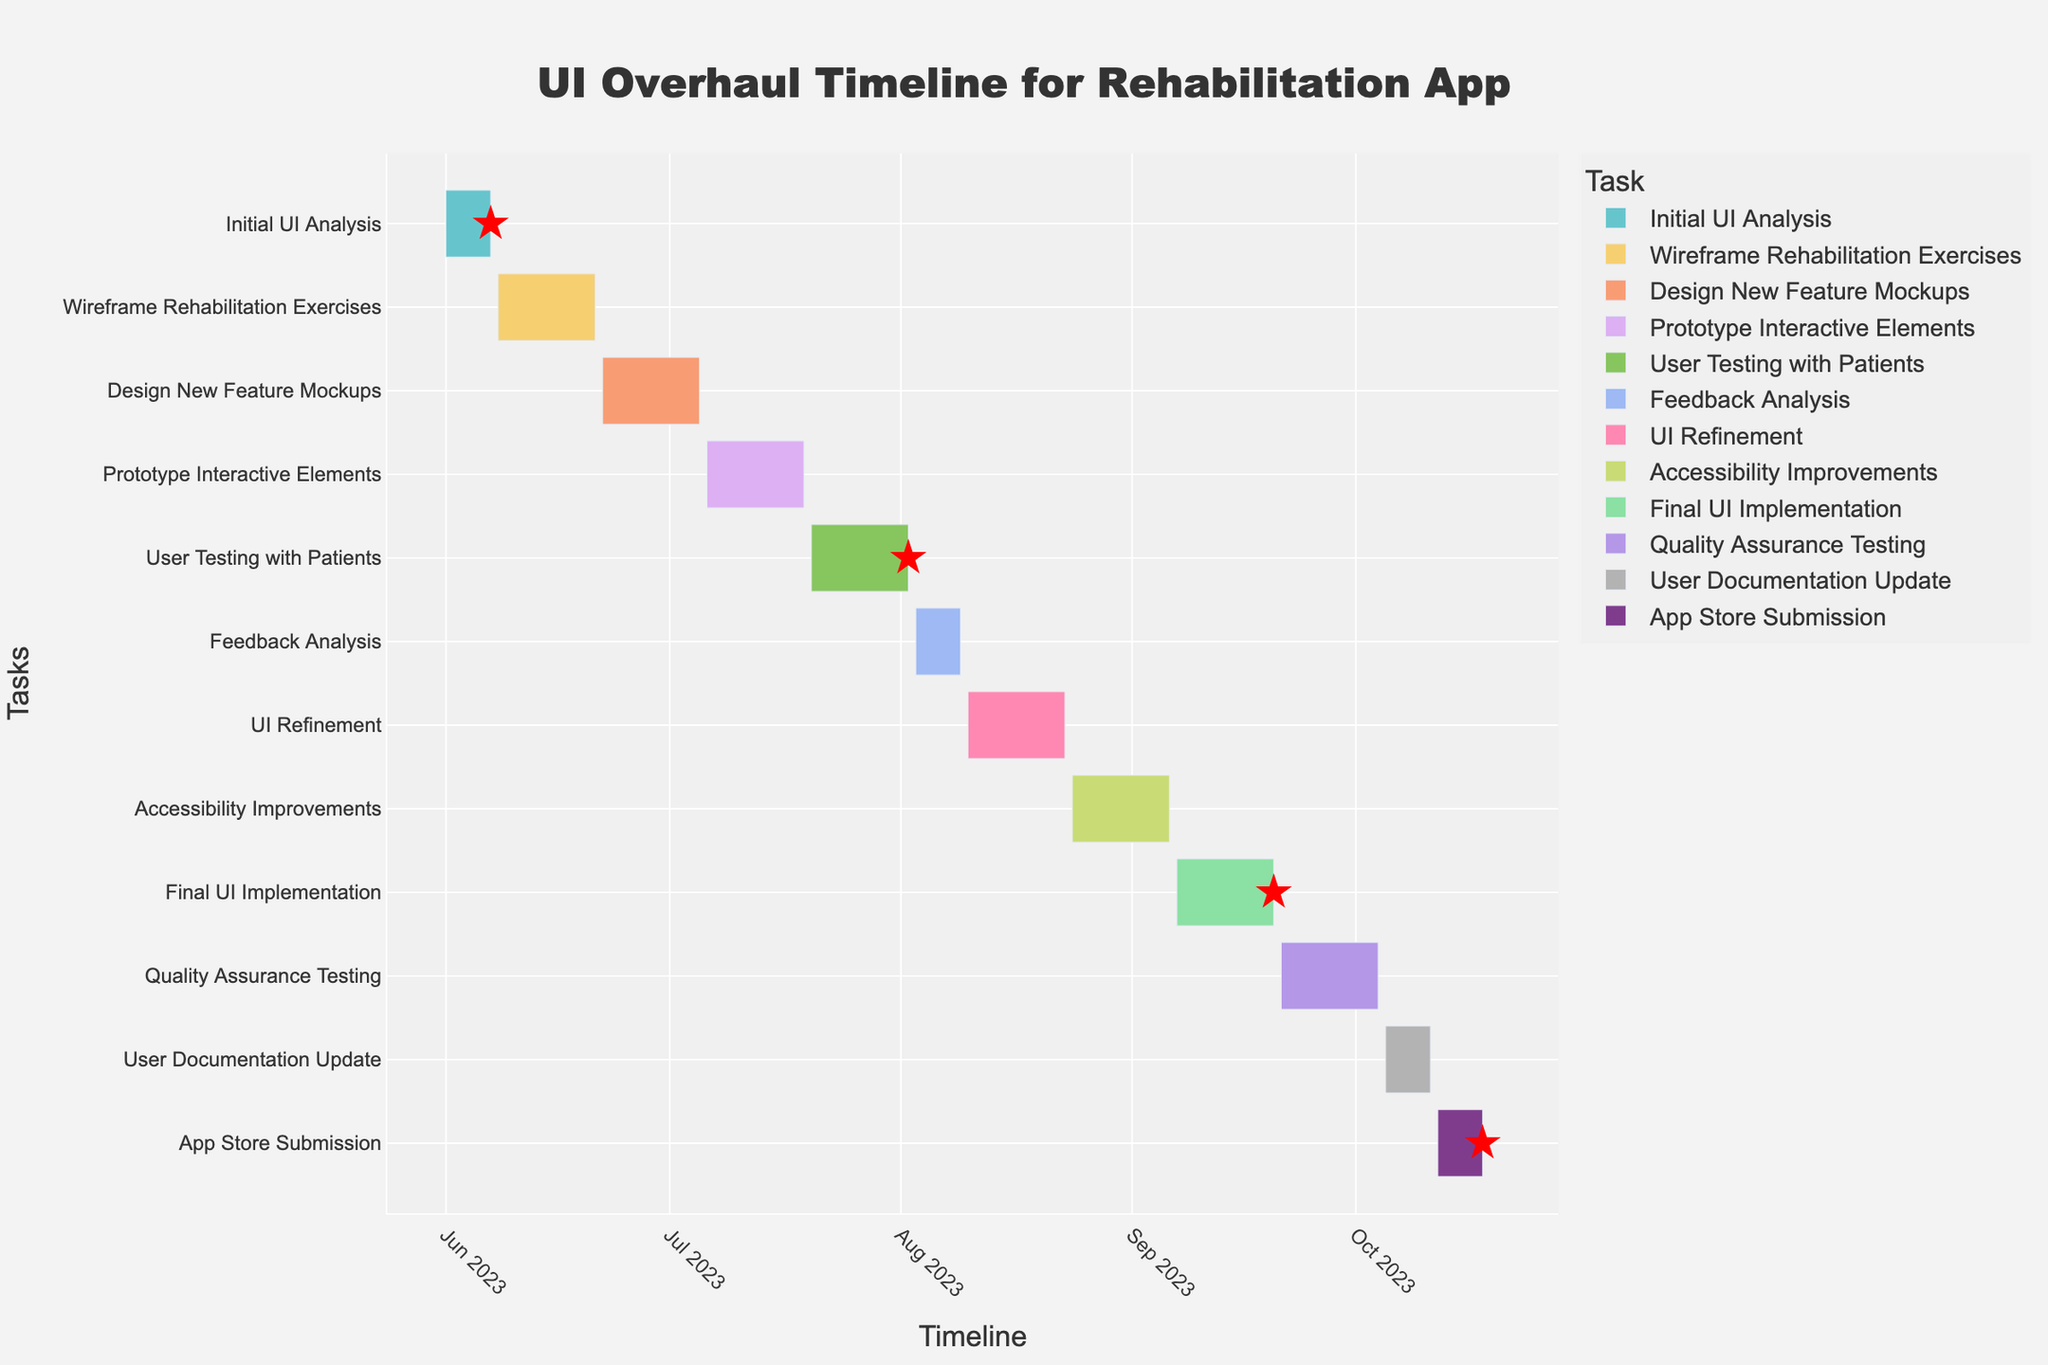What is the title of the Gantt Chart? The title is displayed at the top center of the chart, indicating the overall purpose of the visual. The title of the Gantt Chart reads "UI Overhaul Timeline for Rehabilitation App".
Answer: UI Overhaul Timeline for Rehabilitation App How long is the duration for the "Wireframe Rehabilitation Exercises" task? The "Wireframe Rehabilitation Exercises" task is represented by a bar on the Gantt Chart, and the duration is indicated in days. By referring to the hover information or the duration column, we can see it lasts for 14 days.
Answer: 14 days Between which dates does the "User Testing with Patients" phase occur? The "User Testing with Patients" bar is shown on the Gantt Chart with both start and end dates visible. It starts on July 20, 2023, and ends on August 2, 2023.
Answer: July 20, 2023 - August 2, 2023 Which task is scheduled immediately after "Feedback Analysis"? To determine this, we look at the end date of "Feedback Analysis" and then check the start date of the subsequent task. "Feedback Analysis" ends on August 9, 2023, and the next task, "UI Refinement," starts on August 10, 2023.
Answer: UI Refinement How long is the "Final UI Implementation" task, and when does it start? The "Final UI Implementation" task duration is shown on the Gantt Chart, and the start date is identified at the beginning of the corresponding bar. The task duration is 14 days, starting on September 7, 2023.
Answer: 14 days, starts on September 7, 2023 Which tasks are classified as milestones, and why? Milestones are specific points marked on the Gantt Chart, such as with a special symbol like a star. By looking at the chart, we can see the milestones are "Initial UI Analysis," "User Testing with Patients," "Final UI Implementation," and "App Store Submission." These tasks are crucial phases or checkpoints in the timeline.
Answer: Initial UI Analysis, User Testing with Patients, Final UI Implementation, App Store Submission Which task has the shortest duration, and how many days does it take? By examining the duration of each task on the Gantt Chart, we find that both "Feedback Analysis" and "User Documentation Update" have the shortest durations, each lasting 7 days.
Answer: Feedback Analysis, 7 days Calculate the total number of days from the start of "Initial UI Analysis" to the end of "App Store Submission." The "Initial UI Analysis" starts on June 1, 2023, and "App Store Submission" ends on October 18, 2023. We calculate the total number of days by counting the days between these two dates.
Answer: 140 days Are there any overlapping tasks, and if so, which ones? To identify overlapping tasks, we check if the end date of one task falls after the start date of another task. There are no overlapping tasks on this Gantt Chart; each task starts immediately after the previous one ends.
Answer: No Which task takes place in the month of August entirely? By checking the date range for each task, we see that "UI Refinement" starts on August 10, 2023, and ends on August 23, 2023, which is the only task that occurs entirely within August.
Answer: UI Refinement 